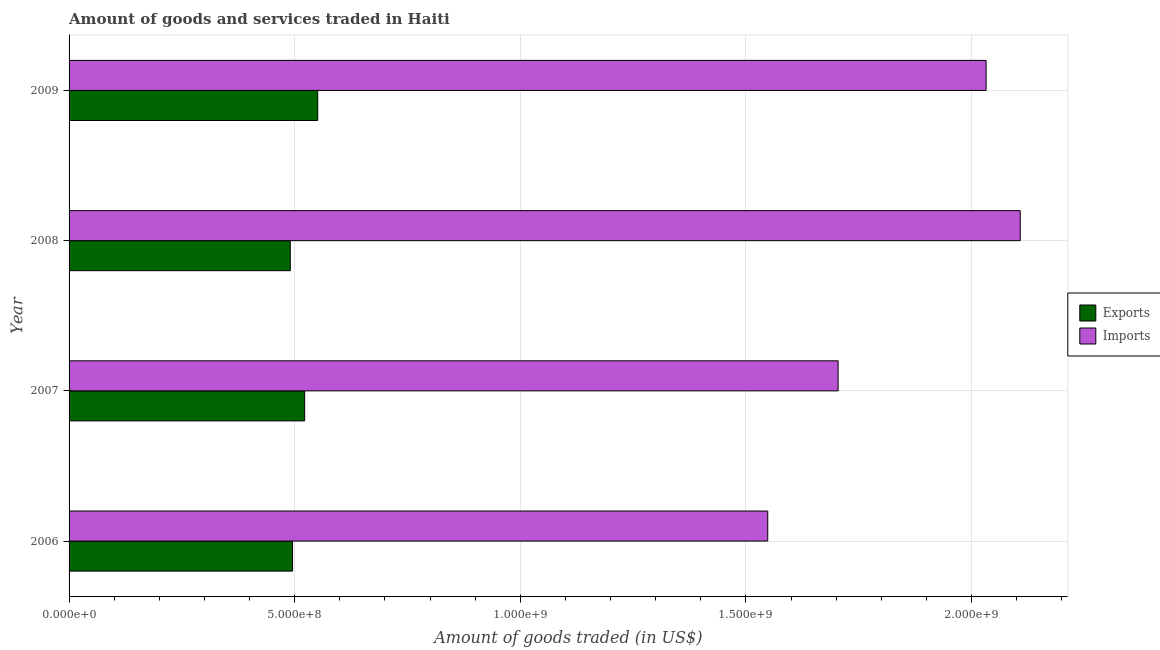Are the number of bars on each tick of the Y-axis equal?
Give a very brief answer. Yes. In how many cases, is the number of bars for a given year not equal to the number of legend labels?
Give a very brief answer. 0. What is the amount of goods imported in 2006?
Keep it short and to the point. 1.55e+09. Across all years, what is the maximum amount of goods exported?
Ensure brevity in your answer.  5.51e+08. Across all years, what is the minimum amount of goods exported?
Offer a terse response. 4.90e+08. In which year was the amount of goods exported minimum?
Keep it short and to the point. 2008. What is the total amount of goods exported in the graph?
Your response must be concise. 2.06e+09. What is the difference between the amount of goods imported in 2007 and that in 2009?
Make the answer very short. -3.28e+08. What is the difference between the amount of goods imported in 2008 and the amount of goods exported in 2006?
Give a very brief answer. 1.61e+09. What is the average amount of goods imported per year?
Your response must be concise. 1.85e+09. In the year 2008, what is the difference between the amount of goods exported and amount of goods imported?
Offer a very short reply. -1.62e+09. What is the ratio of the amount of goods imported in 2006 to that in 2009?
Make the answer very short. 0.76. Is the amount of goods imported in 2007 less than that in 2009?
Give a very brief answer. Yes. What is the difference between the highest and the second highest amount of goods imported?
Offer a terse response. 7.56e+07. What is the difference between the highest and the lowest amount of goods exported?
Your response must be concise. 6.08e+07. In how many years, is the amount of goods exported greater than the average amount of goods exported taken over all years?
Offer a very short reply. 2. What does the 1st bar from the top in 2006 represents?
Provide a succinct answer. Imports. What does the 1st bar from the bottom in 2006 represents?
Your answer should be compact. Exports. How many bars are there?
Provide a succinct answer. 8. How many years are there in the graph?
Offer a terse response. 4. What is the difference between two consecutive major ticks on the X-axis?
Ensure brevity in your answer.  5.00e+08. Does the graph contain grids?
Offer a terse response. Yes. Where does the legend appear in the graph?
Provide a short and direct response. Center right. What is the title of the graph?
Make the answer very short. Amount of goods and services traded in Haiti. Does "Foreign liabilities" appear as one of the legend labels in the graph?
Provide a succinct answer. No. What is the label or title of the X-axis?
Ensure brevity in your answer.  Amount of goods traded (in US$). What is the label or title of the Y-axis?
Your response must be concise. Year. What is the Amount of goods traded (in US$) of Exports in 2006?
Make the answer very short. 4.95e+08. What is the Amount of goods traded (in US$) in Imports in 2006?
Provide a succinct answer. 1.55e+09. What is the Amount of goods traded (in US$) of Exports in 2007?
Keep it short and to the point. 5.22e+08. What is the Amount of goods traded (in US$) of Imports in 2007?
Offer a terse response. 1.70e+09. What is the Amount of goods traded (in US$) in Exports in 2008?
Keep it short and to the point. 4.90e+08. What is the Amount of goods traded (in US$) in Imports in 2008?
Offer a terse response. 2.11e+09. What is the Amount of goods traded (in US$) in Exports in 2009?
Your answer should be very brief. 5.51e+08. What is the Amount of goods traded (in US$) of Imports in 2009?
Keep it short and to the point. 2.03e+09. Across all years, what is the maximum Amount of goods traded (in US$) of Exports?
Your answer should be very brief. 5.51e+08. Across all years, what is the maximum Amount of goods traded (in US$) of Imports?
Offer a very short reply. 2.11e+09. Across all years, what is the minimum Amount of goods traded (in US$) of Exports?
Offer a very short reply. 4.90e+08. Across all years, what is the minimum Amount of goods traded (in US$) of Imports?
Ensure brevity in your answer.  1.55e+09. What is the total Amount of goods traded (in US$) in Exports in the graph?
Give a very brief answer. 2.06e+09. What is the total Amount of goods traded (in US$) of Imports in the graph?
Your answer should be very brief. 7.39e+09. What is the difference between the Amount of goods traded (in US$) of Exports in 2006 and that in 2007?
Your answer should be compact. -2.69e+07. What is the difference between the Amount of goods traded (in US$) in Imports in 2006 and that in 2007?
Your response must be concise. -1.56e+08. What is the difference between the Amount of goods traded (in US$) of Exports in 2006 and that in 2008?
Your response must be concise. 4.98e+06. What is the difference between the Amount of goods traded (in US$) in Imports in 2006 and that in 2008?
Make the answer very short. -5.60e+08. What is the difference between the Amount of goods traded (in US$) in Exports in 2006 and that in 2009?
Give a very brief answer. -5.58e+07. What is the difference between the Amount of goods traded (in US$) in Imports in 2006 and that in 2009?
Give a very brief answer. -4.84e+08. What is the difference between the Amount of goods traded (in US$) of Exports in 2007 and that in 2008?
Offer a terse response. 3.19e+07. What is the difference between the Amount of goods traded (in US$) in Imports in 2007 and that in 2008?
Offer a very short reply. -4.04e+08. What is the difference between the Amount of goods traded (in US$) in Exports in 2007 and that in 2009?
Your answer should be compact. -2.89e+07. What is the difference between the Amount of goods traded (in US$) of Imports in 2007 and that in 2009?
Give a very brief answer. -3.28e+08. What is the difference between the Amount of goods traded (in US$) of Exports in 2008 and that in 2009?
Provide a short and direct response. -6.08e+07. What is the difference between the Amount of goods traded (in US$) of Imports in 2008 and that in 2009?
Your answer should be compact. 7.56e+07. What is the difference between the Amount of goods traded (in US$) of Exports in 2006 and the Amount of goods traded (in US$) of Imports in 2007?
Make the answer very short. -1.21e+09. What is the difference between the Amount of goods traded (in US$) of Exports in 2006 and the Amount of goods traded (in US$) of Imports in 2008?
Give a very brief answer. -1.61e+09. What is the difference between the Amount of goods traded (in US$) of Exports in 2006 and the Amount of goods traded (in US$) of Imports in 2009?
Offer a terse response. -1.54e+09. What is the difference between the Amount of goods traded (in US$) of Exports in 2007 and the Amount of goods traded (in US$) of Imports in 2008?
Keep it short and to the point. -1.59e+09. What is the difference between the Amount of goods traded (in US$) of Exports in 2007 and the Amount of goods traded (in US$) of Imports in 2009?
Your answer should be very brief. -1.51e+09. What is the difference between the Amount of goods traded (in US$) of Exports in 2008 and the Amount of goods traded (in US$) of Imports in 2009?
Keep it short and to the point. -1.54e+09. What is the average Amount of goods traded (in US$) in Exports per year?
Make the answer very short. 5.15e+08. What is the average Amount of goods traded (in US$) of Imports per year?
Your answer should be compact. 1.85e+09. In the year 2006, what is the difference between the Amount of goods traded (in US$) in Exports and Amount of goods traded (in US$) in Imports?
Your answer should be compact. -1.05e+09. In the year 2007, what is the difference between the Amount of goods traded (in US$) of Exports and Amount of goods traded (in US$) of Imports?
Offer a terse response. -1.18e+09. In the year 2008, what is the difference between the Amount of goods traded (in US$) of Exports and Amount of goods traded (in US$) of Imports?
Offer a terse response. -1.62e+09. In the year 2009, what is the difference between the Amount of goods traded (in US$) of Exports and Amount of goods traded (in US$) of Imports?
Your answer should be very brief. -1.48e+09. What is the ratio of the Amount of goods traded (in US$) of Exports in 2006 to that in 2007?
Keep it short and to the point. 0.95. What is the ratio of the Amount of goods traded (in US$) of Imports in 2006 to that in 2007?
Offer a terse response. 0.91. What is the ratio of the Amount of goods traded (in US$) of Exports in 2006 to that in 2008?
Your answer should be compact. 1.01. What is the ratio of the Amount of goods traded (in US$) of Imports in 2006 to that in 2008?
Offer a terse response. 0.73. What is the ratio of the Amount of goods traded (in US$) in Exports in 2006 to that in 2009?
Provide a short and direct response. 0.9. What is the ratio of the Amount of goods traded (in US$) in Imports in 2006 to that in 2009?
Offer a very short reply. 0.76. What is the ratio of the Amount of goods traded (in US$) of Exports in 2007 to that in 2008?
Your response must be concise. 1.06. What is the ratio of the Amount of goods traded (in US$) of Imports in 2007 to that in 2008?
Provide a succinct answer. 0.81. What is the ratio of the Amount of goods traded (in US$) in Exports in 2007 to that in 2009?
Ensure brevity in your answer.  0.95. What is the ratio of the Amount of goods traded (in US$) in Imports in 2007 to that in 2009?
Your answer should be compact. 0.84. What is the ratio of the Amount of goods traded (in US$) in Exports in 2008 to that in 2009?
Offer a very short reply. 0.89. What is the ratio of the Amount of goods traded (in US$) of Imports in 2008 to that in 2009?
Your response must be concise. 1.04. What is the difference between the highest and the second highest Amount of goods traded (in US$) in Exports?
Make the answer very short. 2.89e+07. What is the difference between the highest and the second highest Amount of goods traded (in US$) of Imports?
Ensure brevity in your answer.  7.56e+07. What is the difference between the highest and the lowest Amount of goods traded (in US$) in Exports?
Ensure brevity in your answer.  6.08e+07. What is the difference between the highest and the lowest Amount of goods traded (in US$) in Imports?
Provide a short and direct response. 5.60e+08. 